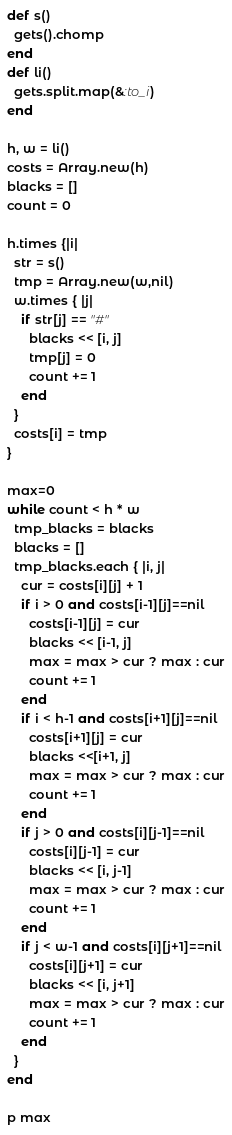Convert code to text. <code><loc_0><loc_0><loc_500><loc_500><_Ruby_>def s()
  gets().chomp
end
def li()
  gets.split.map(&:to_i)
end

h, w = li()
costs = Array.new(h)
blacks = []
count = 0

h.times {|i|
  str = s()
  tmp = Array.new(w,nil)
  w.times { |j|
    if str[j] == "#"
      blacks << [i, j]
      tmp[j] = 0
      count += 1
    end
  }
  costs[i] = tmp
}

max=0
while count < h * w
  tmp_blacks = blacks
  blacks = []
  tmp_blacks.each { |i, j|
    cur = costs[i][j] + 1
    if i > 0 and costs[i-1][j]==nil
      costs[i-1][j] = cur
      blacks << [i-1, j]
      max = max > cur ? max : cur
      count += 1
    end
    if i < h-1 and costs[i+1][j]==nil
      costs[i+1][j] = cur
      blacks <<[i+1, j]
      max = max > cur ? max : cur
      count += 1
    end
    if j > 0 and costs[i][j-1]==nil
      costs[i][j-1] = cur
      blacks << [i, j-1]
      max = max > cur ? max : cur
      count += 1
    end
    if j < w-1 and costs[i][j+1]==nil
      costs[i][j+1] = cur
      blacks << [i, j+1]
      max = max > cur ? max : cur
      count += 1
    end
  }
end

p max</code> 